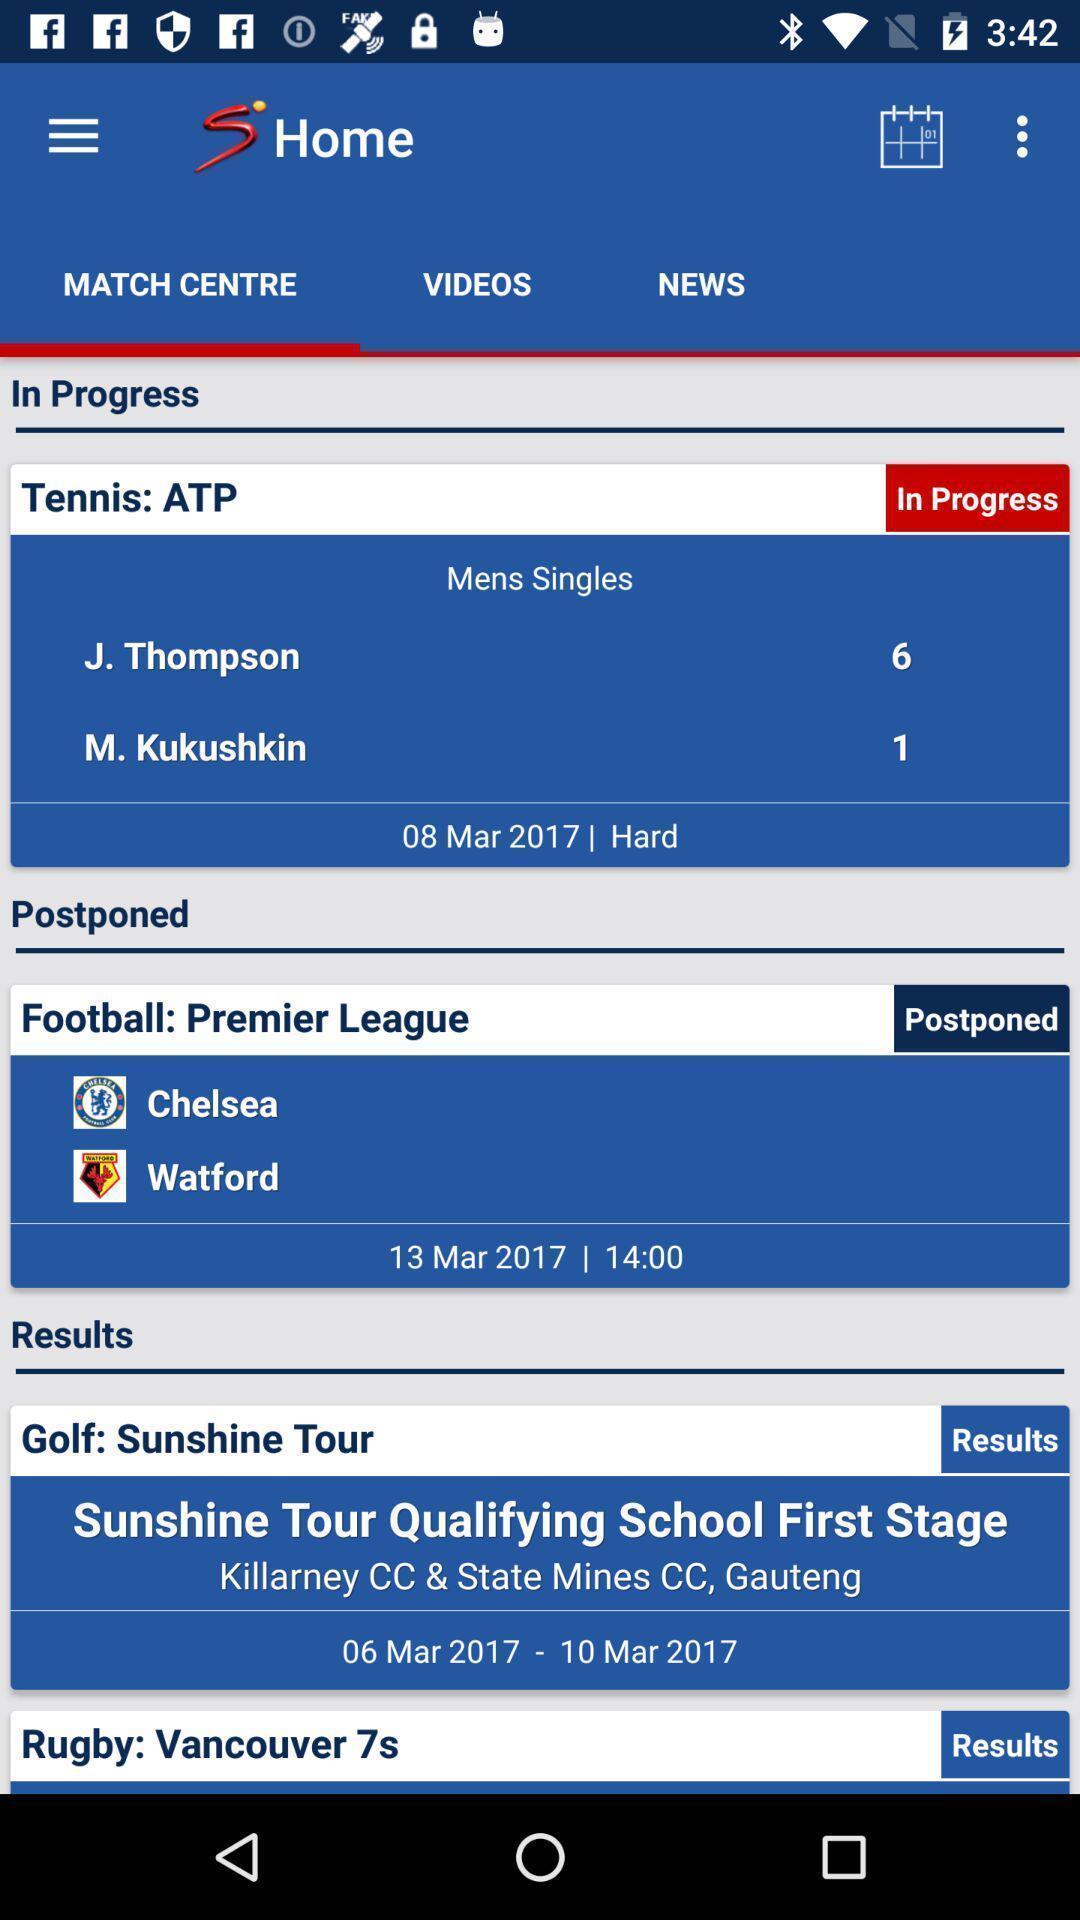What details can you identify in this image? Page showing match center in an sports application. 